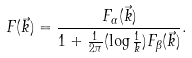<formula> <loc_0><loc_0><loc_500><loc_500>F ( \vec { k } ) = \frac { F _ { \alpha } ( \vec { k } ) } { 1 + \frac { 1 } { 2 \pi } ( \log \frac { 1 } { k } ) F _ { \beta } ( \vec { k } ) } .</formula> 